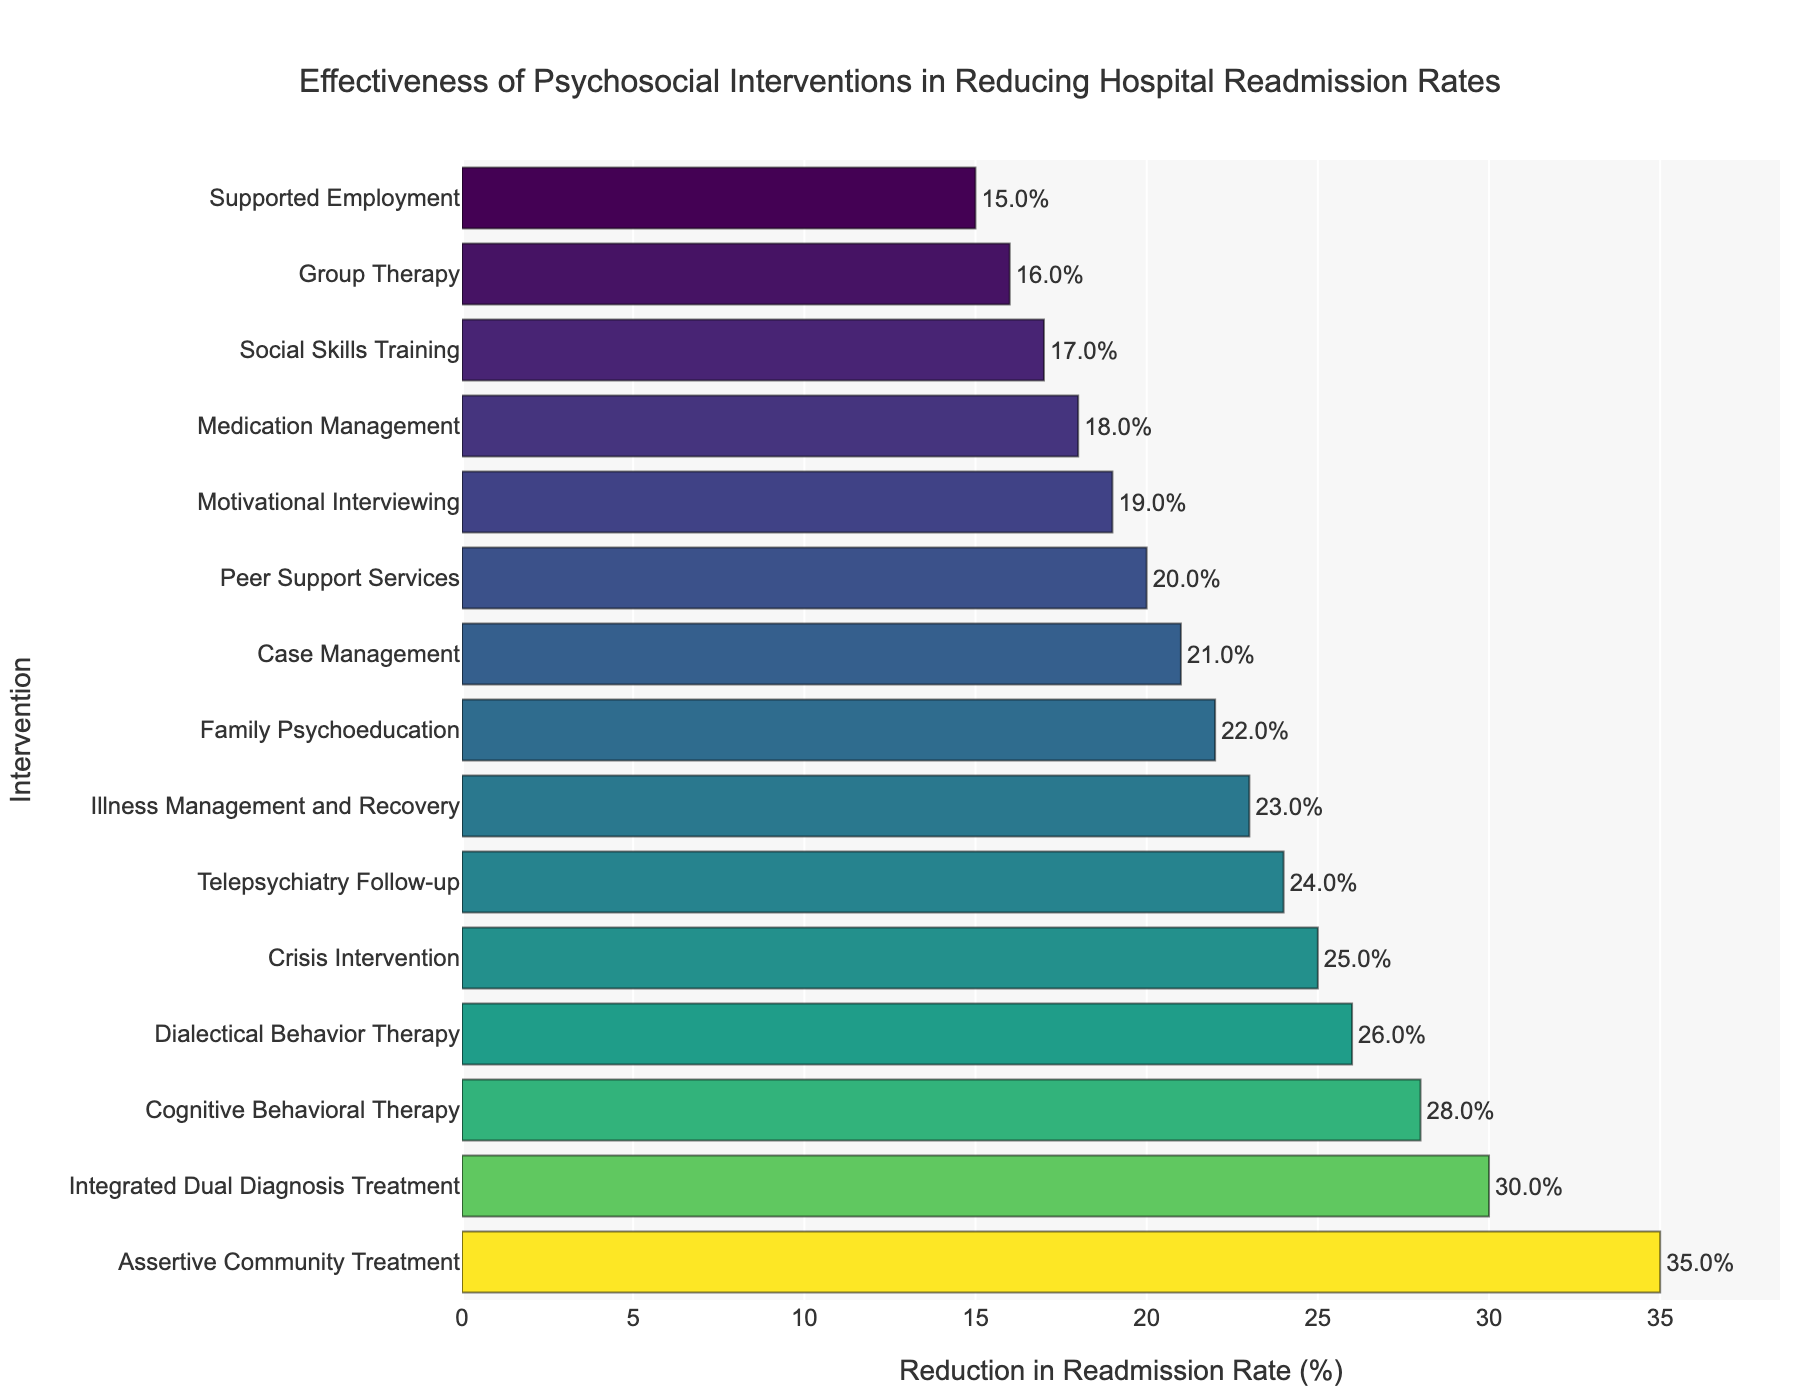What is the most effective intervention in reducing hospital readmission rates for psychiatric patients? Observing the bar chart, the intervention with the highest reduction in readmission rates is the longest bar on the horizontal axis.
Answer: Assertive Community Treatment Which intervention is the least effective in reducing hospital readmission rates? The shortest bar represents the intervention with the least reduction in readmission rates.
Answer: Supported Employment How much more effective is Cognitive Behavioral Therapy than Supported Employment? Subtract the reduction rate of Supported Employment (15%) from that of Cognitive Behavioral Therapy (28%). 28% - 15% = 13%
Answer: 13% What is the average reduction in readmission rates across all interventions? Sum all the reduction rates and divide by the number of interventions: (28 + 22 + 35 + 18 + 15 + 20 + 25 + 17 + 30 + 23 + 19 + 26 + 21 + 16 + 24) / 15 = 24%.
Answer: 24% Which two interventions have the closest reduction rates, and what is the difference between them? The bars of Family Psychoeducation (22%) and Illness Management and Recovery (23%) are very close; their difference is 23% - 22% = 1%.
Answer: Family Psychoeducation and Illness Management and Recovery, 1% Between Crisis Intervention and Telepsychiatry Follow-up, which is more effective, and by how much? Crisis Intervention has a reduction rate of 25%, and Telepsychiatry Follow-up has 24%. The difference is 25% - 24% = 1%.
Answer: Crisis Intervention, 1% Rank the top three interventions in terms of their effectiveness in reducing readmission rates. The three longest bars represent the top three interventions: Assertive Community Treatment (35%), Integrated Dual Diagnosis Treatment (30%), and Cognitive Behavioral Therapy (28%).
Answer: Assertive Community Treatment, Integrated Dual Diagnosis Treatment, Cognitive Behavioral Therapy What is the median reduction rate among the interventions? List all reduction rates in ascending order and find the middle value: (15, 16, 17, 18, 19, 20, 21, 22, 23, 24, 25, 26, 28, 30, 35). The median value is the 8th value: 23%.
Answer: 23% Which intervention reduces hospital readmission rates by approximately one-fourth? Look for the bar closest to 25%. Crisis Intervention has a reduction rate of 25%.
Answer: Crisis Intervention How does the effectiveness of Dialectical Behavior Therapy compare to that of Peer Support Services? Dialectical Behavior Therapy has a reduction rate of 26%, and Peer Support Services have 20%. 26% is greater than 20%.
Answer: Dialectical Behavior Therapy, greater than Peer Support Services 